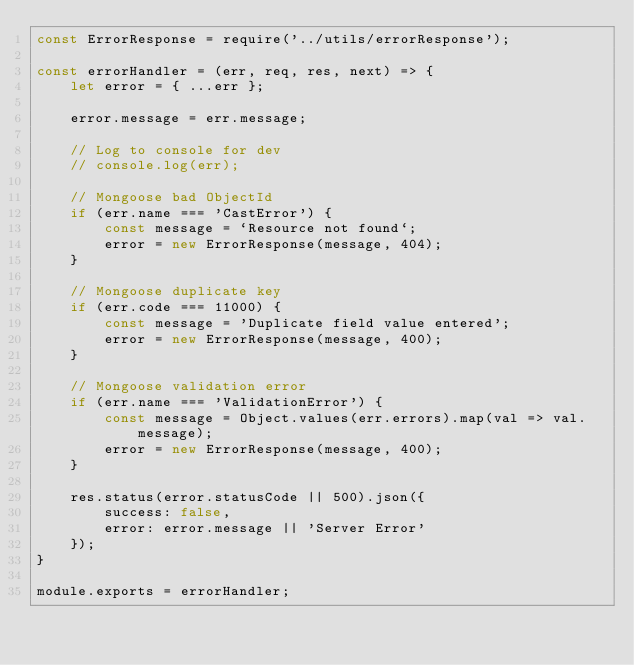Convert code to text. <code><loc_0><loc_0><loc_500><loc_500><_JavaScript_>const ErrorResponse = require('../utils/errorResponse');

const errorHandler = (err, req, res, next) => {
    let error = { ...err };

    error.message = err.message;

    // Log to console for dev
    // console.log(err);

    // Mongoose bad ObjectId
    if (err.name === 'CastError') {
        const message = `Resource not found`;
        error = new ErrorResponse(message, 404);
    }

    // Mongoose duplicate key
    if (err.code === 11000) {
        const message = 'Duplicate field value entered';
        error = new ErrorResponse(message, 400);
    } 

    // Mongoose validation error
    if (err.name === 'ValidationError') {
        const message = Object.values(err.errors).map(val => val.message);
        error = new ErrorResponse(message, 400);
    }

    res.status(error.statusCode || 500).json({
        success: false,
        error: error.message || 'Server Error'
    });
}

module.exports = errorHandler;</code> 